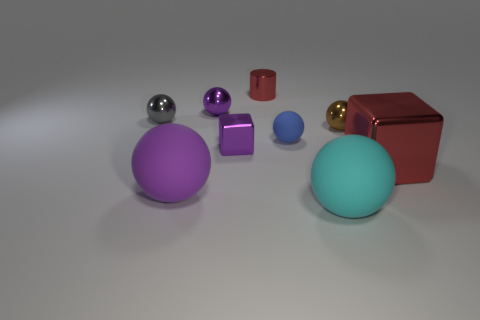Is the size of the red metal cube behind the purple rubber object the same as the purple sphere in front of the small gray object?
Offer a terse response. Yes. There is a red metal object left of the small blue ball; what shape is it?
Offer a very short reply. Cylinder. There is a blue thing that is the same shape as the big cyan object; what is its material?
Offer a very short reply. Rubber. There is a purple shiny object that is behind the brown thing; is its size the same as the small red cylinder?
Your response must be concise. Yes. What number of tiny brown spheres are on the right side of the small metal block?
Your response must be concise. 1. Are there fewer matte things that are on the right side of the purple rubber sphere than objects left of the small red cylinder?
Give a very brief answer. Yes. What number of purple rubber things are there?
Provide a short and direct response. 1. There is a large matte object left of the small rubber object; what color is it?
Make the answer very short. Purple. How big is the red metal block?
Provide a succinct answer. Large. There is a small metal cube; does it have the same color as the big rubber thing left of the small metallic block?
Make the answer very short. Yes. 